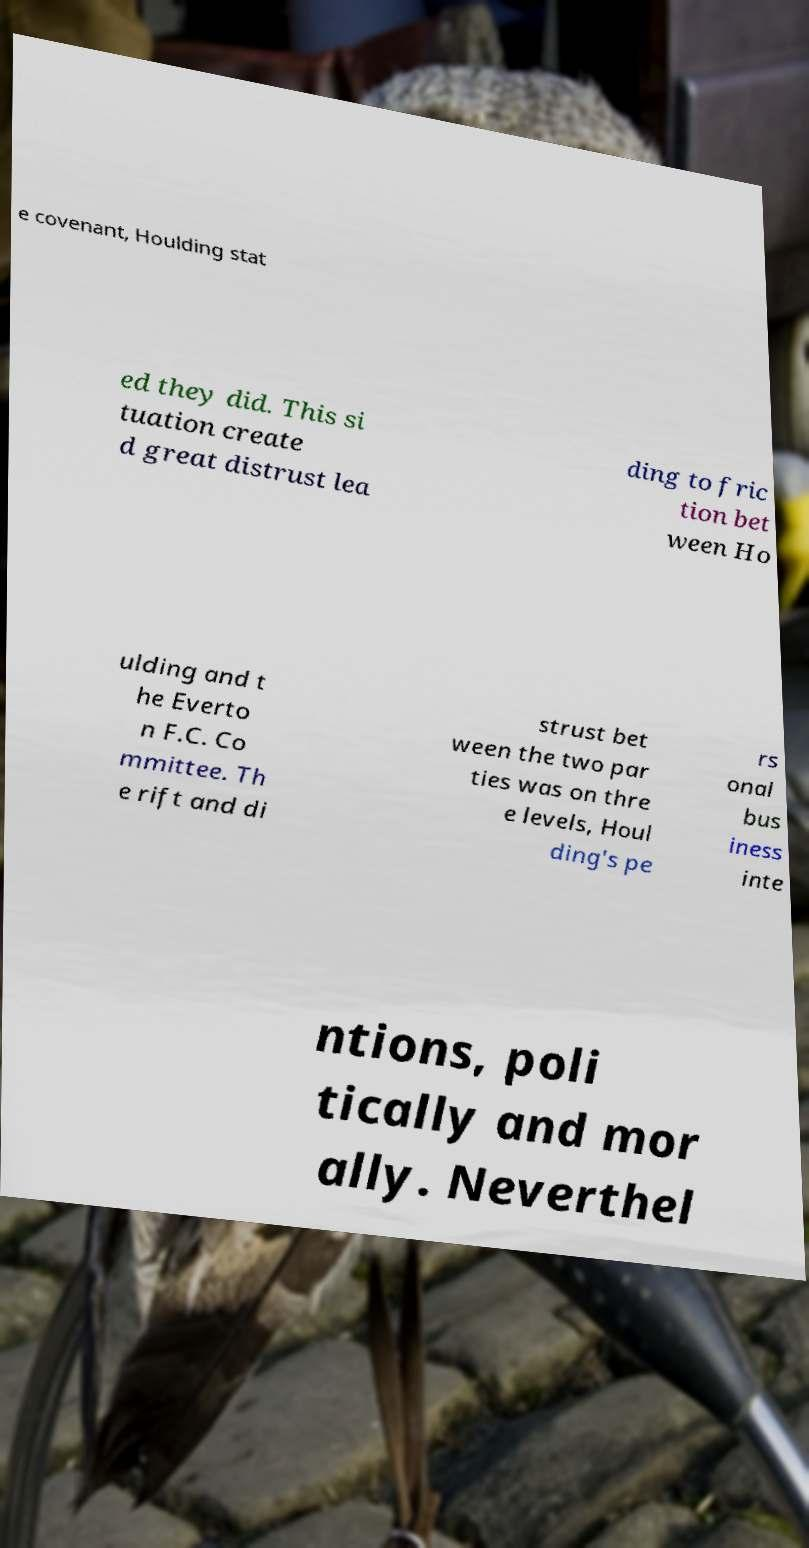Can you read and provide the text displayed in the image?This photo seems to have some interesting text. Can you extract and type it out for me? e covenant, Houlding stat ed they did. This si tuation create d great distrust lea ding to fric tion bet ween Ho ulding and t he Everto n F.C. Co mmittee. Th e rift and di strust bet ween the two par ties was on thre e levels, Houl ding's pe rs onal bus iness inte ntions, poli tically and mor ally. Neverthel 